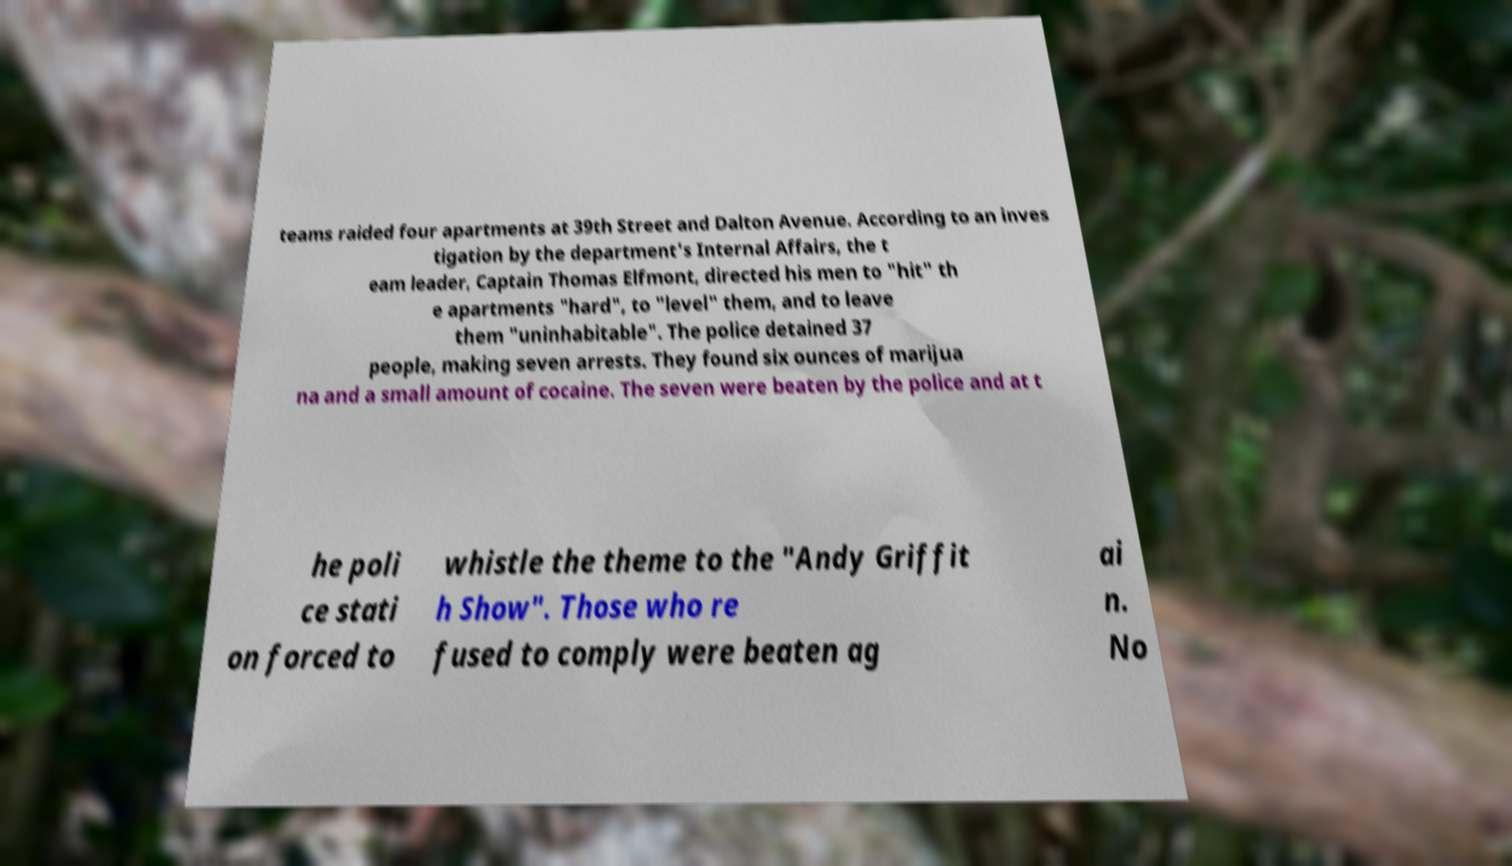Please identify and transcribe the text found in this image. teams raided four apartments at 39th Street and Dalton Avenue. According to an inves tigation by the department's Internal Affairs, the t eam leader, Captain Thomas Elfmont, directed his men to "hit" th e apartments "hard", to "level" them, and to leave them "uninhabitable". The police detained 37 people, making seven arrests. They found six ounces of marijua na and a small amount of cocaine. The seven were beaten by the police and at t he poli ce stati on forced to whistle the theme to the "Andy Griffit h Show". Those who re fused to comply were beaten ag ai n. No 